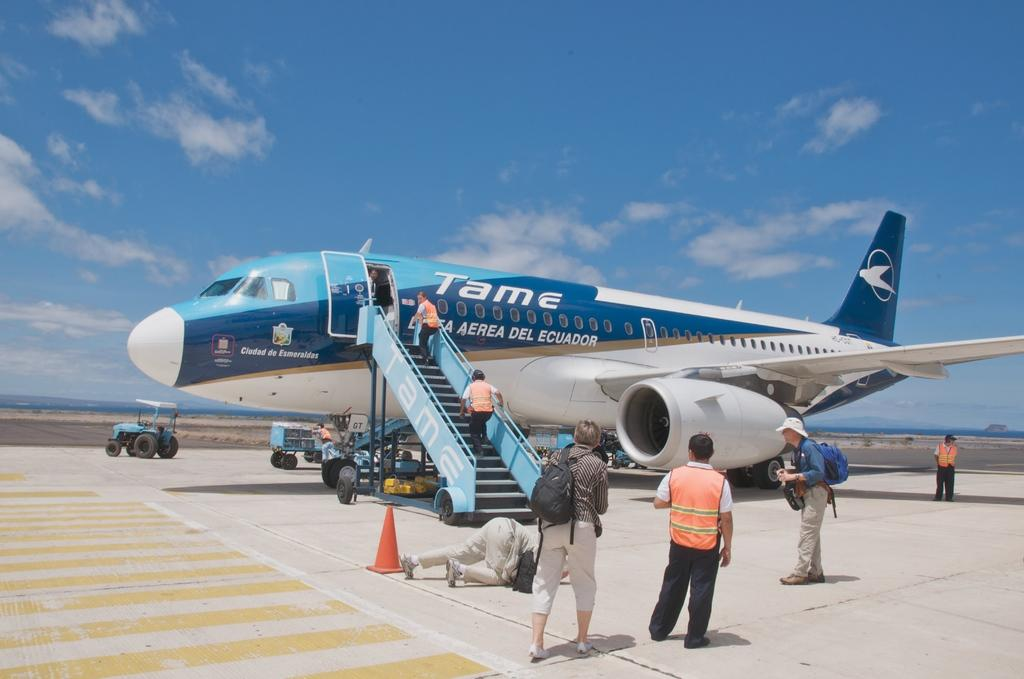<image>
Provide a brief description of the given image. The Tame airplane has its steps down for boarding 